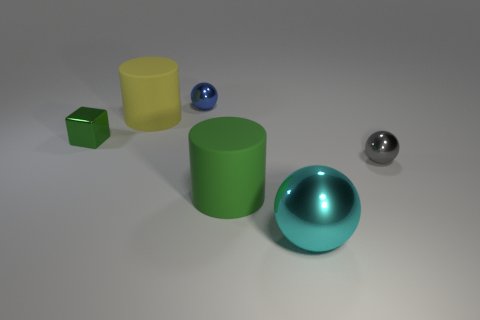There is a thing that is behind the small cube and on the left side of the blue metallic ball; how big is it?
Give a very brief answer. Large. What shape is the large green matte object?
Your response must be concise. Cylinder. Is there a green shiny block in front of the big rubber cylinder that is behind the tiny block?
Your answer should be very brief. Yes. What material is the green cylinder that is the same size as the yellow matte object?
Provide a succinct answer. Rubber. Is there a metal cube of the same size as the gray sphere?
Your answer should be compact. Yes. There is a cylinder in front of the large yellow matte cylinder; what is it made of?
Offer a terse response. Rubber. Is the tiny sphere on the left side of the big cyan shiny sphere made of the same material as the cyan object?
Offer a terse response. Yes. What is the shape of the blue thing that is the same size as the gray shiny ball?
Keep it short and to the point. Sphere. How many large matte things have the same color as the cube?
Offer a very short reply. 1. Is the number of big cyan objects to the right of the big metallic sphere less than the number of big matte cylinders that are in front of the green shiny cube?
Ensure brevity in your answer.  Yes. 